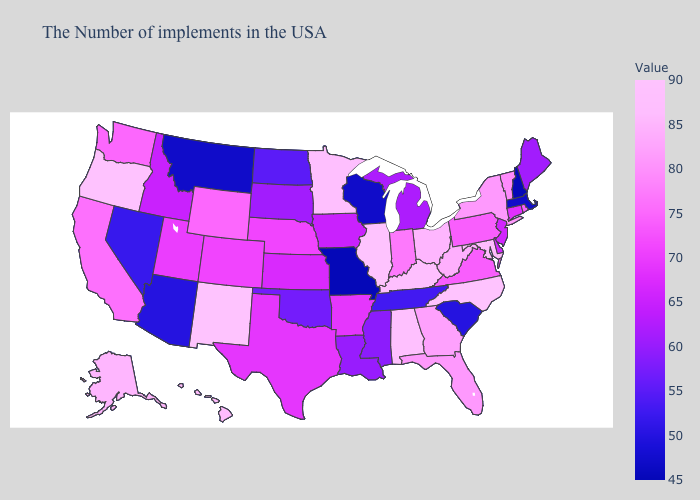Does Illinois have the highest value in the MidWest?
Give a very brief answer. Yes. Does Delaware have a higher value than Nevada?
Quick response, please. Yes. Does Virginia have a lower value than Montana?
Write a very short answer. No. 